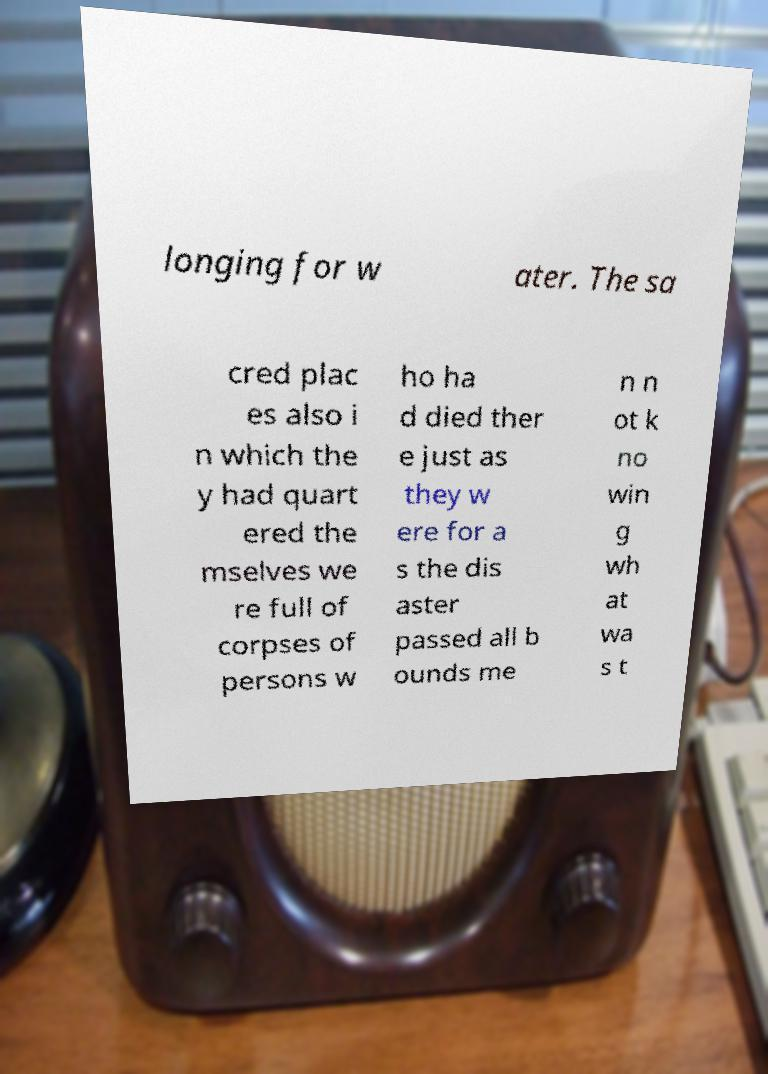For documentation purposes, I need the text within this image transcribed. Could you provide that? longing for w ater. The sa cred plac es also i n which the y had quart ered the mselves we re full of corpses of persons w ho ha d died ther e just as they w ere for a s the dis aster passed all b ounds me n n ot k no win g wh at wa s t 